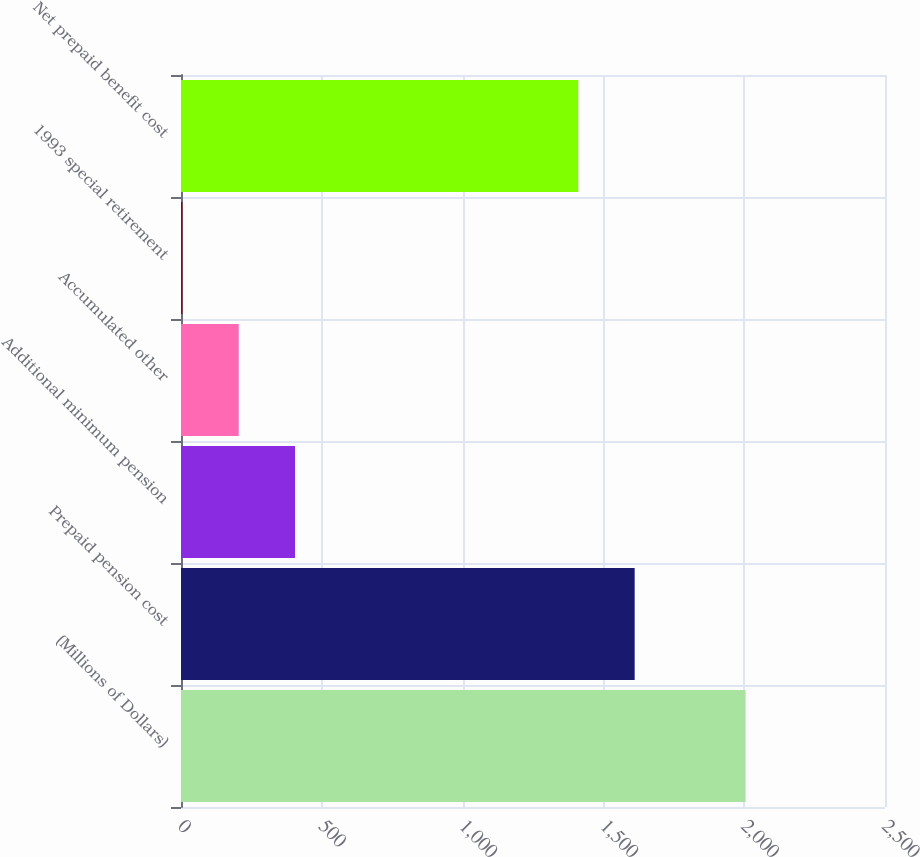Convert chart. <chart><loc_0><loc_0><loc_500><loc_500><bar_chart><fcel>(Millions of Dollars)<fcel>Prepaid pension cost<fcel>Additional minimum pension<fcel>Accumulated other<fcel>1993 special retirement<fcel>Net prepaid benefit cost<nl><fcel>2005<fcel>1611<fcel>405<fcel>205<fcel>5<fcel>1411<nl></chart> 